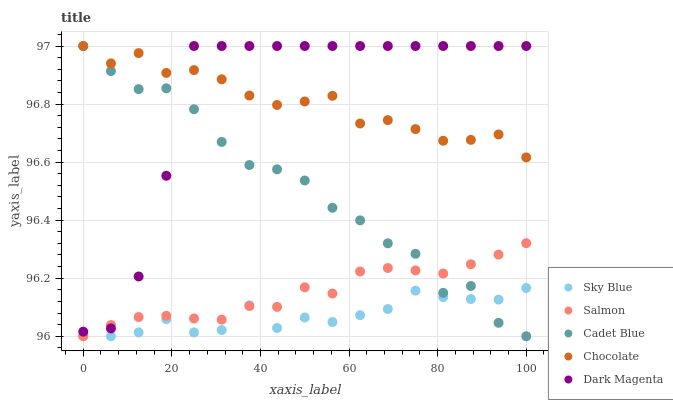Does Sky Blue have the minimum area under the curve?
Answer yes or no. Yes. Does Dark Magenta have the maximum area under the curve?
Answer yes or no. Yes. Does Cadet Blue have the minimum area under the curve?
Answer yes or no. No. Does Cadet Blue have the maximum area under the curve?
Answer yes or no. No. Is Salmon the smoothest?
Answer yes or no. Yes. Is Cadet Blue the roughest?
Answer yes or no. Yes. Is Cadet Blue the smoothest?
Answer yes or no. No. Is Salmon the roughest?
Answer yes or no. No. Does Sky Blue have the lowest value?
Answer yes or no. Yes. Does Dark Magenta have the lowest value?
Answer yes or no. No. Does Chocolate have the highest value?
Answer yes or no. Yes. Does Salmon have the highest value?
Answer yes or no. No. Is Sky Blue less than Dark Magenta?
Answer yes or no. Yes. Is Dark Magenta greater than Sky Blue?
Answer yes or no. Yes. Does Dark Magenta intersect Chocolate?
Answer yes or no. Yes. Is Dark Magenta less than Chocolate?
Answer yes or no. No. Is Dark Magenta greater than Chocolate?
Answer yes or no. No. Does Sky Blue intersect Dark Magenta?
Answer yes or no. No. 